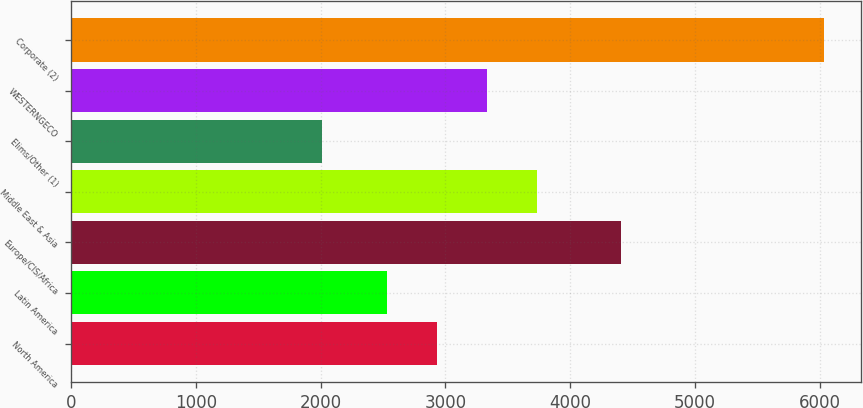Convert chart to OTSL. <chart><loc_0><loc_0><loc_500><loc_500><bar_chart><fcel>North America<fcel>Latin America<fcel>Europe/CIS/Africa<fcel>Middle East & Asia<fcel>Elims/Other (1)<fcel>WESTERNGECO<fcel>Corporate (2)<nl><fcel>2930.7<fcel>2529<fcel>4410<fcel>3734.1<fcel>2014<fcel>3332.4<fcel>6031<nl></chart> 